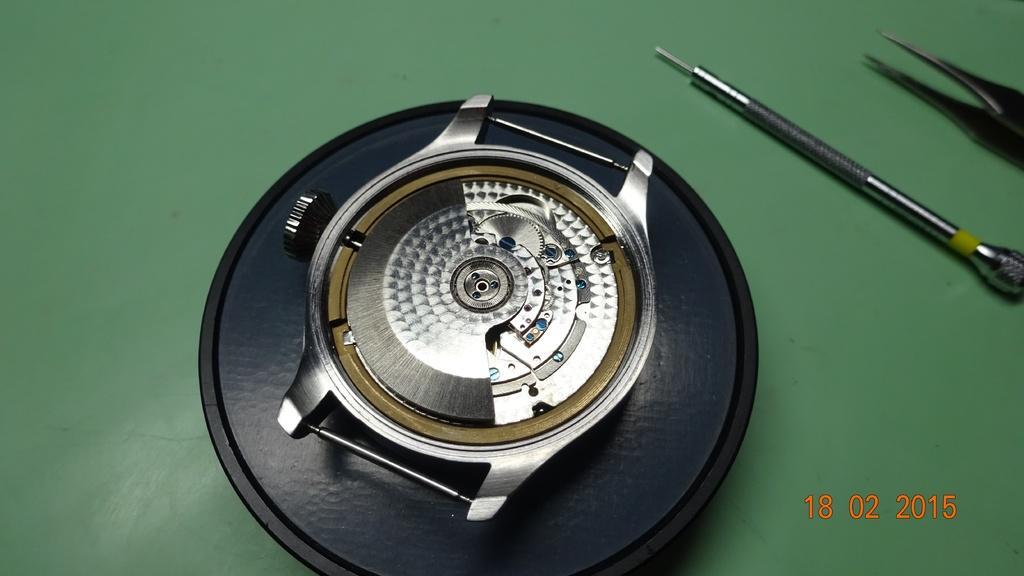Could you give a brief overview of what you see in this image? In this picture I can see a watch dial. In the right side I can see few Instruments. At the right bottom there is some text. 